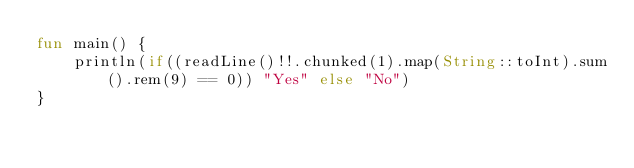Convert code to text. <code><loc_0><loc_0><loc_500><loc_500><_Kotlin_>fun main() {
    println(if((readLine()!!.chunked(1).map(String::toInt).sum().rem(9) == 0)) "Yes" else "No")
}</code> 